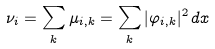Convert formula to latex. <formula><loc_0><loc_0><loc_500><loc_500>\nu _ { i } = \sum _ { k } \mu _ { i , k } = \sum _ { k } | \varphi _ { i , k } | ^ { 2 } \, d x</formula> 